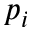Convert formula to latex. <formula><loc_0><loc_0><loc_500><loc_500>p _ { i }</formula> 